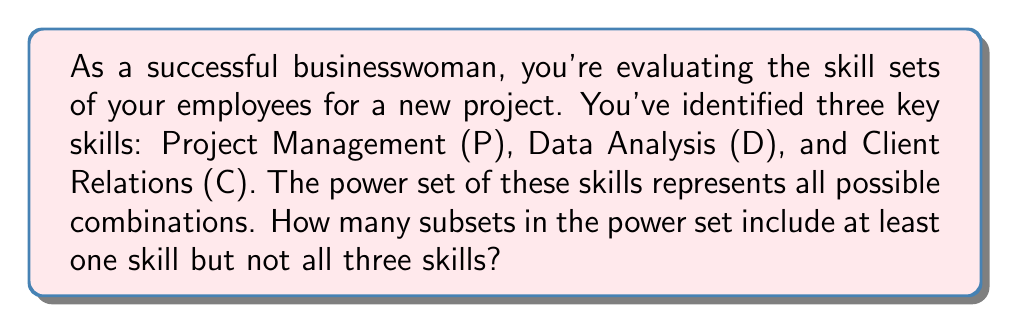Teach me how to tackle this problem. Let's approach this step-by-step:

1) First, let's define our set of skills:
   $S = \{P, D, C\}$

2) The power set of S, denoted as $P(S)$, contains all possible subsets of S, including the empty set and S itself.

3) The total number of elements in the power set is given by $2^n$, where n is the number of elements in the original set. Here, $n = 3$, so:
   $|P(S)| = 2^3 = 8$

4) The power set $P(S)$ consists of:
   $\{\emptyset, \{P\}, \{D\}, \{C\}, \{P,D\}, \{P,C\}, \{D,C\}, \{P,D,C\}\}$

5) We need to count the subsets that include at least one skill but not all three. This means we need to exclude:
   - The empty set $\emptyset$
   - The full set $\{P,D,C\}$

6) Counting the remaining subsets:
   $\{P\}, \{D\}, \{C\}, \{P,D\}, \{P,C\}, \{D,C\}$

7) Therefore, the number of subsets that meet our criteria is 6.

This approach allows you to systematically evaluate all possible skill combinations among your employees, which is crucial for efficient project planning and resource allocation in your business.
Answer: 6 subsets 